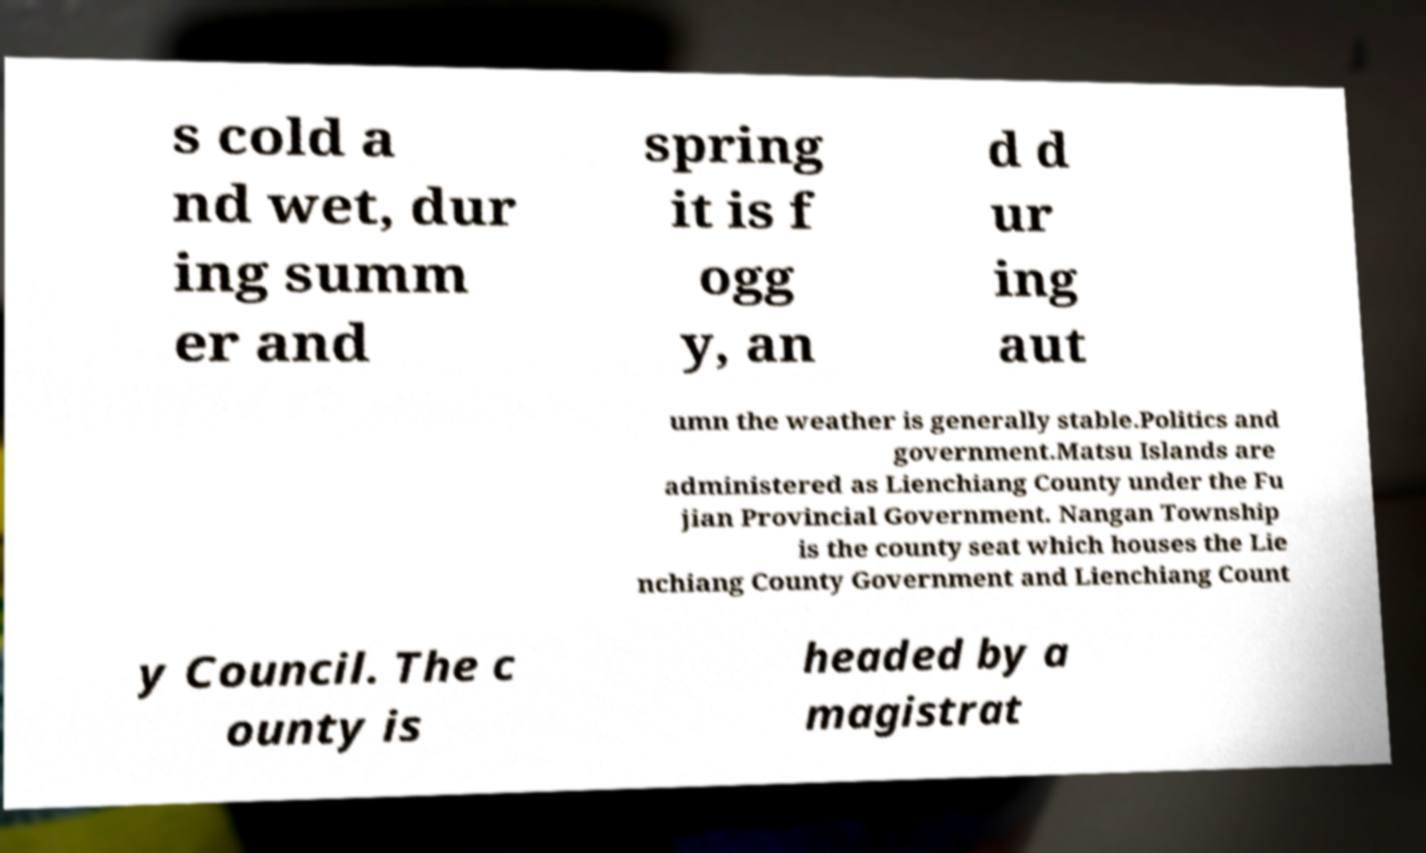Please read and relay the text visible in this image. What does it say? s cold a nd wet, dur ing summ er and spring it is f ogg y, an d d ur ing aut umn the weather is generally stable.Politics and government.Matsu Islands are administered as Lienchiang County under the Fu jian Provincial Government. Nangan Township is the county seat which houses the Lie nchiang County Government and Lienchiang Count y Council. The c ounty is headed by a magistrat 